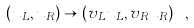Convert formula to latex. <formula><loc_0><loc_0><loc_500><loc_500>( u _ { L } , u _ { R } ) \to ( v _ { L } u _ { L } , v _ { R } u _ { R } ) \ ,</formula> 